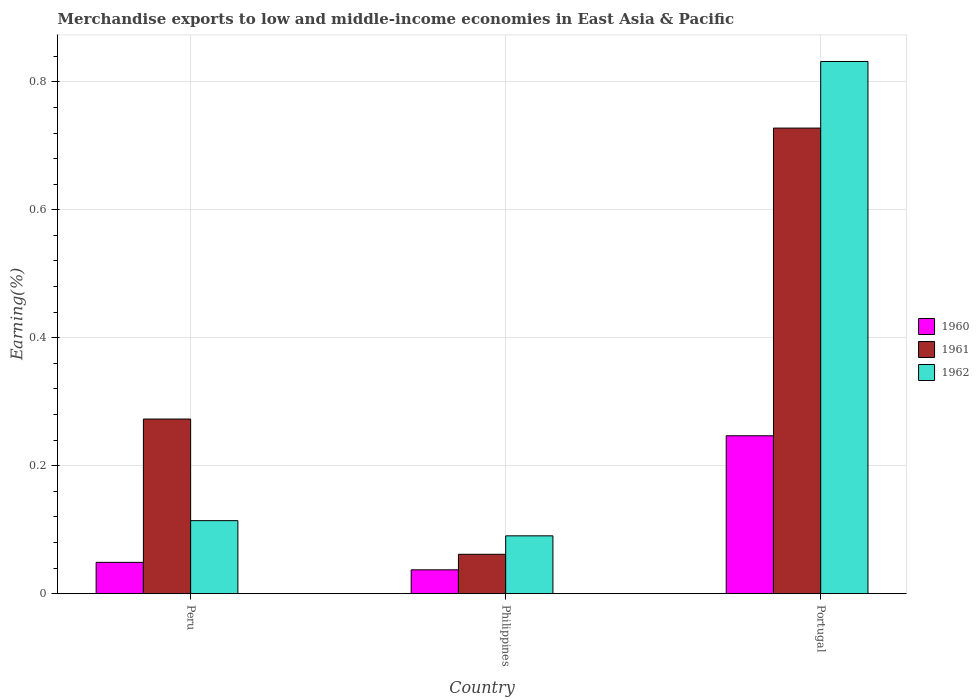How many groups of bars are there?
Your answer should be compact. 3. Are the number of bars per tick equal to the number of legend labels?
Provide a short and direct response. Yes. Are the number of bars on each tick of the X-axis equal?
Your answer should be very brief. Yes. How many bars are there on the 1st tick from the left?
Your answer should be compact. 3. How many bars are there on the 2nd tick from the right?
Your response must be concise. 3. In how many cases, is the number of bars for a given country not equal to the number of legend labels?
Offer a very short reply. 0. What is the percentage of amount earned from merchandise exports in 1962 in Peru?
Your response must be concise. 0.11. Across all countries, what is the maximum percentage of amount earned from merchandise exports in 1960?
Your answer should be compact. 0.25. Across all countries, what is the minimum percentage of amount earned from merchandise exports in 1962?
Keep it short and to the point. 0.09. In which country was the percentage of amount earned from merchandise exports in 1962 maximum?
Ensure brevity in your answer.  Portugal. In which country was the percentage of amount earned from merchandise exports in 1961 minimum?
Ensure brevity in your answer.  Philippines. What is the total percentage of amount earned from merchandise exports in 1960 in the graph?
Your answer should be very brief. 0.33. What is the difference between the percentage of amount earned from merchandise exports in 1960 in Philippines and that in Portugal?
Offer a very short reply. -0.21. What is the difference between the percentage of amount earned from merchandise exports in 1962 in Portugal and the percentage of amount earned from merchandise exports in 1961 in Philippines?
Provide a succinct answer. 0.77. What is the average percentage of amount earned from merchandise exports in 1962 per country?
Offer a terse response. 0.35. What is the difference between the percentage of amount earned from merchandise exports of/in 1960 and percentage of amount earned from merchandise exports of/in 1962 in Peru?
Your answer should be compact. -0.07. In how many countries, is the percentage of amount earned from merchandise exports in 1961 greater than 0.24000000000000002 %?
Offer a terse response. 2. What is the ratio of the percentage of amount earned from merchandise exports in 1960 in Peru to that in Philippines?
Keep it short and to the point. 1.31. Is the percentage of amount earned from merchandise exports in 1962 in Peru less than that in Philippines?
Your answer should be compact. No. Is the difference between the percentage of amount earned from merchandise exports in 1960 in Peru and Philippines greater than the difference between the percentage of amount earned from merchandise exports in 1962 in Peru and Philippines?
Your answer should be compact. No. What is the difference between the highest and the second highest percentage of amount earned from merchandise exports in 1962?
Your response must be concise. 0.74. What is the difference between the highest and the lowest percentage of amount earned from merchandise exports in 1962?
Make the answer very short. 0.74. In how many countries, is the percentage of amount earned from merchandise exports in 1961 greater than the average percentage of amount earned from merchandise exports in 1961 taken over all countries?
Your answer should be very brief. 1. Are all the bars in the graph horizontal?
Offer a very short reply. No. Are the values on the major ticks of Y-axis written in scientific E-notation?
Give a very brief answer. No. Does the graph contain any zero values?
Ensure brevity in your answer.  No. Where does the legend appear in the graph?
Offer a terse response. Center right. How are the legend labels stacked?
Keep it short and to the point. Vertical. What is the title of the graph?
Provide a succinct answer. Merchandise exports to low and middle-income economies in East Asia & Pacific. Does "1995" appear as one of the legend labels in the graph?
Give a very brief answer. No. What is the label or title of the Y-axis?
Give a very brief answer. Earning(%). What is the Earning(%) in 1960 in Peru?
Provide a succinct answer. 0.05. What is the Earning(%) of 1961 in Peru?
Your answer should be compact. 0.27. What is the Earning(%) of 1962 in Peru?
Your response must be concise. 0.11. What is the Earning(%) of 1960 in Philippines?
Provide a succinct answer. 0.04. What is the Earning(%) in 1961 in Philippines?
Give a very brief answer. 0.06. What is the Earning(%) in 1962 in Philippines?
Your answer should be compact. 0.09. What is the Earning(%) of 1960 in Portugal?
Offer a very short reply. 0.25. What is the Earning(%) in 1961 in Portugal?
Keep it short and to the point. 0.73. What is the Earning(%) of 1962 in Portugal?
Provide a short and direct response. 0.83. Across all countries, what is the maximum Earning(%) in 1960?
Ensure brevity in your answer.  0.25. Across all countries, what is the maximum Earning(%) in 1961?
Keep it short and to the point. 0.73. Across all countries, what is the maximum Earning(%) of 1962?
Offer a very short reply. 0.83. Across all countries, what is the minimum Earning(%) of 1960?
Your answer should be compact. 0.04. Across all countries, what is the minimum Earning(%) of 1961?
Ensure brevity in your answer.  0.06. Across all countries, what is the minimum Earning(%) of 1962?
Your answer should be compact. 0.09. What is the total Earning(%) in 1960 in the graph?
Ensure brevity in your answer.  0.33. What is the total Earning(%) of 1961 in the graph?
Make the answer very short. 1.06. What is the total Earning(%) in 1962 in the graph?
Your response must be concise. 1.04. What is the difference between the Earning(%) of 1960 in Peru and that in Philippines?
Provide a short and direct response. 0.01. What is the difference between the Earning(%) of 1961 in Peru and that in Philippines?
Keep it short and to the point. 0.21. What is the difference between the Earning(%) of 1962 in Peru and that in Philippines?
Provide a short and direct response. 0.02. What is the difference between the Earning(%) in 1960 in Peru and that in Portugal?
Make the answer very short. -0.2. What is the difference between the Earning(%) of 1961 in Peru and that in Portugal?
Your answer should be very brief. -0.45. What is the difference between the Earning(%) of 1962 in Peru and that in Portugal?
Keep it short and to the point. -0.72. What is the difference between the Earning(%) of 1960 in Philippines and that in Portugal?
Offer a terse response. -0.21. What is the difference between the Earning(%) of 1961 in Philippines and that in Portugal?
Offer a very short reply. -0.67. What is the difference between the Earning(%) in 1962 in Philippines and that in Portugal?
Give a very brief answer. -0.74. What is the difference between the Earning(%) of 1960 in Peru and the Earning(%) of 1961 in Philippines?
Provide a succinct answer. -0.01. What is the difference between the Earning(%) in 1960 in Peru and the Earning(%) in 1962 in Philippines?
Offer a terse response. -0.04. What is the difference between the Earning(%) of 1961 in Peru and the Earning(%) of 1962 in Philippines?
Offer a terse response. 0.18. What is the difference between the Earning(%) of 1960 in Peru and the Earning(%) of 1961 in Portugal?
Offer a terse response. -0.68. What is the difference between the Earning(%) in 1960 in Peru and the Earning(%) in 1962 in Portugal?
Offer a very short reply. -0.78. What is the difference between the Earning(%) of 1961 in Peru and the Earning(%) of 1962 in Portugal?
Your answer should be compact. -0.56. What is the difference between the Earning(%) in 1960 in Philippines and the Earning(%) in 1961 in Portugal?
Your answer should be very brief. -0.69. What is the difference between the Earning(%) of 1960 in Philippines and the Earning(%) of 1962 in Portugal?
Your response must be concise. -0.79. What is the difference between the Earning(%) in 1961 in Philippines and the Earning(%) in 1962 in Portugal?
Provide a short and direct response. -0.77. What is the average Earning(%) in 1960 per country?
Keep it short and to the point. 0.11. What is the average Earning(%) in 1961 per country?
Your response must be concise. 0.35. What is the average Earning(%) of 1962 per country?
Provide a succinct answer. 0.35. What is the difference between the Earning(%) in 1960 and Earning(%) in 1961 in Peru?
Make the answer very short. -0.22. What is the difference between the Earning(%) of 1960 and Earning(%) of 1962 in Peru?
Provide a short and direct response. -0.07. What is the difference between the Earning(%) of 1961 and Earning(%) of 1962 in Peru?
Provide a succinct answer. 0.16. What is the difference between the Earning(%) in 1960 and Earning(%) in 1961 in Philippines?
Offer a terse response. -0.02. What is the difference between the Earning(%) in 1960 and Earning(%) in 1962 in Philippines?
Keep it short and to the point. -0.05. What is the difference between the Earning(%) of 1961 and Earning(%) of 1962 in Philippines?
Your response must be concise. -0.03. What is the difference between the Earning(%) in 1960 and Earning(%) in 1961 in Portugal?
Ensure brevity in your answer.  -0.48. What is the difference between the Earning(%) of 1960 and Earning(%) of 1962 in Portugal?
Offer a terse response. -0.58. What is the difference between the Earning(%) in 1961 and Earning(%) in 1962 in Portugal?
Keep it short and to the point. -0.1. What is the ratio of the Earning(%) in 1960 in Peru to that in Philippines?
Offer a very short reply. 1.31. What is the ratio of the Earning(%) of 1961 in Peru to that in Philippines?
Offer a very short reply. 4.44. What is the ratio of the Earning(%) in 1962 in Peru to that in Philippines?
Your answer should be compact. 1.26. What is the ratio of the Earning(%) in 1960 in Peru to that in Portugal?
Your answer should be very brief. 0.2. What is the ratio of the Earning(%) in 1961 in Peru to that in Portugal?
Make the answer very short. 0.38. What is the ratio of the Earning(%) in 1962 in Peru to that in Portugal?
Make the answer very short. 0.14. What is the ratio of the Earning(%) in 1960 in Philippines to that in Portugal?
Offer a very short reply. 0.15. What is the ratio of the Earning(%) of 1961 in Philippines to that in Portugal?
Your response must be concise. 0.08. What is the ratio of the Earning(%) of 1962 in Philippines to that in Portugal?
Offer a terse response. 0.11. What is the difference between the highest and the second highest Earning(%) of 1960?
Your answer should be compact. 0.2. What is the difference between the highest and the second highest Earning(%) in 1961?
Keep it short and to the point. 0.45. What is the difference between the highest and the second highest Earning(%) of 1962?
Your answer should be compact. 0.72. What is the difference between the highest and the lowest Earning(%) in 1960?
Ensure brevity in your answer.  0.21. What is the difference between the highest and the lowest Earning(%) in 1961?
Keep it short and to the point. 0.67. What is the difference between the highest and the lowest Earning(%) of 1962?
Offer a terse response. 0.74. 